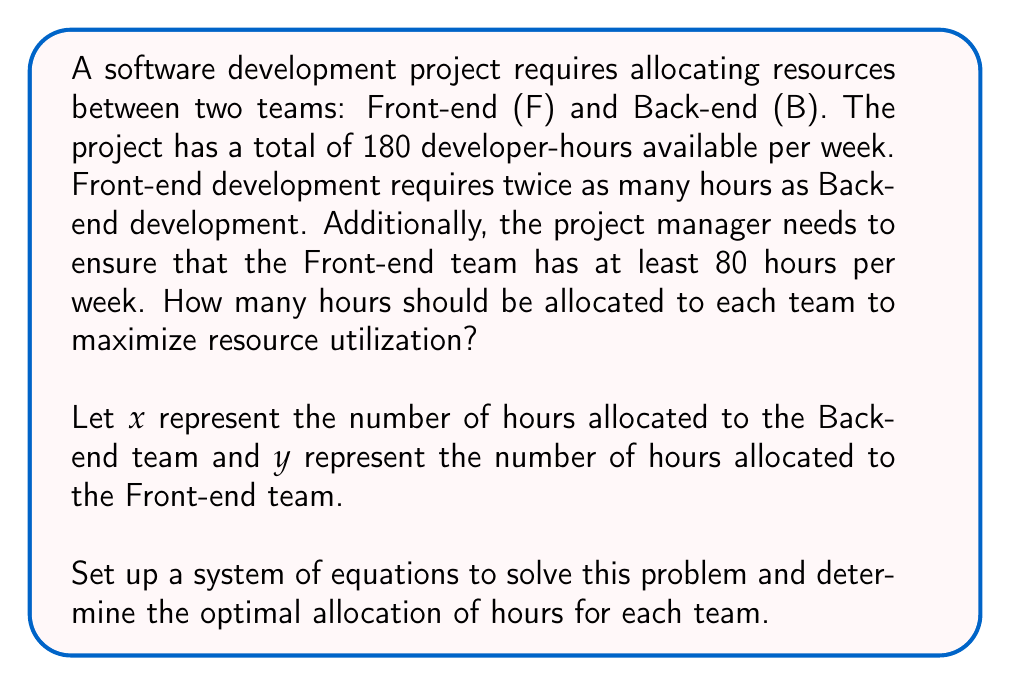Show me your answer to this math problem. Let's approach this step-by-step:

1) First, let's define our variables:
   $x$ = hours allocated to Back-end team
   $y$ = hours allocated to Front-end team

2) Now, let's set up our equations based on the given information:

   a) Total available hours: 
      $$x + y = 180$$

   b) Front-end requires twice as many hours as Back-end:
      $$y = 2x$$

   c) Front-end team needs at least 80 hours:
      $$y \geq 80$$

3) We can solve this system using substitution:
   From equation (b), substitute $y = 2x$ into equation (a):
   
   $$x + 2x = 180$$
   $$3x = 180$$
   $$x = 60$$

4) Now that we know $x$, we can find $y$:
   $$y = 2x = 2(60) = 120$$

5) Let's verify our constraint (c):
   $y = 120$, which is indeed ≥ 80, so this solution satisfies all conditions.

6) Therefore, the optimal allocation is:
   Back-end team (x): 60 hours
   Front-end team (y): 120 hours

This allocation maximizes resource utilization while meeting all the specified constraints.
Answer: Back-end: 60 hours, Front-end: 120 hours 